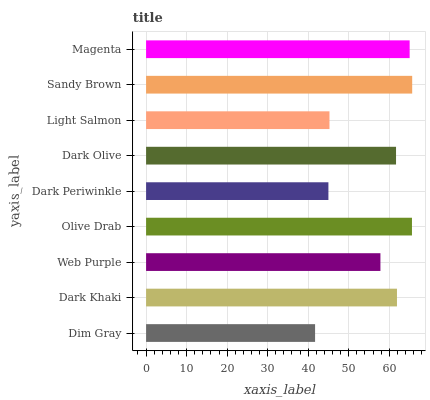Is Dim Gray the minimum?
Answer yes or no. Yes. Is Sandy Brown the maximum?
Answer yes or no. Yes. Is Dark Khaki the minimum?
Answer yes or no. No. Is Dark Khaki the maximum?
Answer yes or no. No. Is Dark Khaki greater than Dim Gray?
Answer yes or no. Yes. Is Dim Gray less than Dark Khaki?
Answer yes or no. Yes. Is Dim Gray greater than Dark Khaki?
Answer yes or no. No. Is Dark Khaki less than Dim Gray?
Answer yes or no. No. Is Dark Olive the high median?
Answer yes or no. Yes. Is Dark Olive the low median?
Answer yes or no. Yes. Is Web Purple the high median?
Answer yes or no. No. Is Dark Periwinkle the low median?
Answer yes or no. No. 